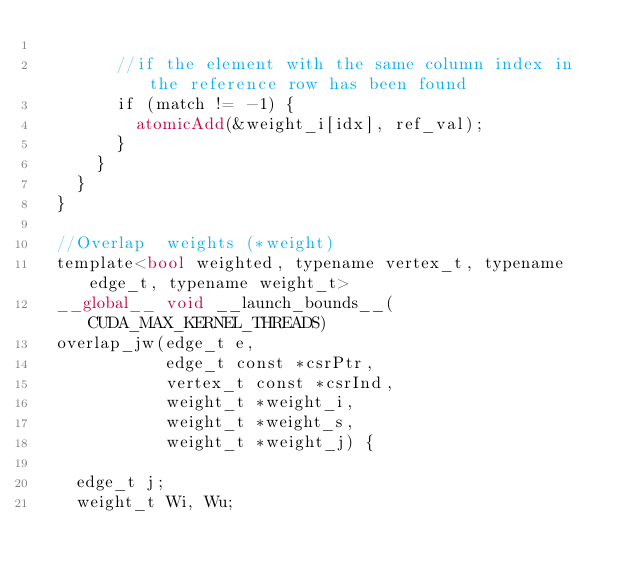<code> <loc_0><loc_0><loc_500><loc_500><_Cuda_>
        //if the element with the same column index in the reference row has been found
        if (match != -1) {
          atomicAdd(&weight_i[idx], ref_val);
        }
      }
    }
  }

  //Overlap  weights (*weight)
  template<bool weighted, typename vertex_t, typename edge_t, typename weight_t>
  __global__ void __launch_bounds__(CUDA_MAX_KERNEL_THREADS)
  overlap_jw(edge_t e,
             edge_t const *csrPtr,
             vertex_t const *csrInd,
             weight_t *weight_i,
             weight_t *weight_s,
             weight_t *weight_j) {

    edge_t j;
    weight_t Wi, Wu;
</code> 